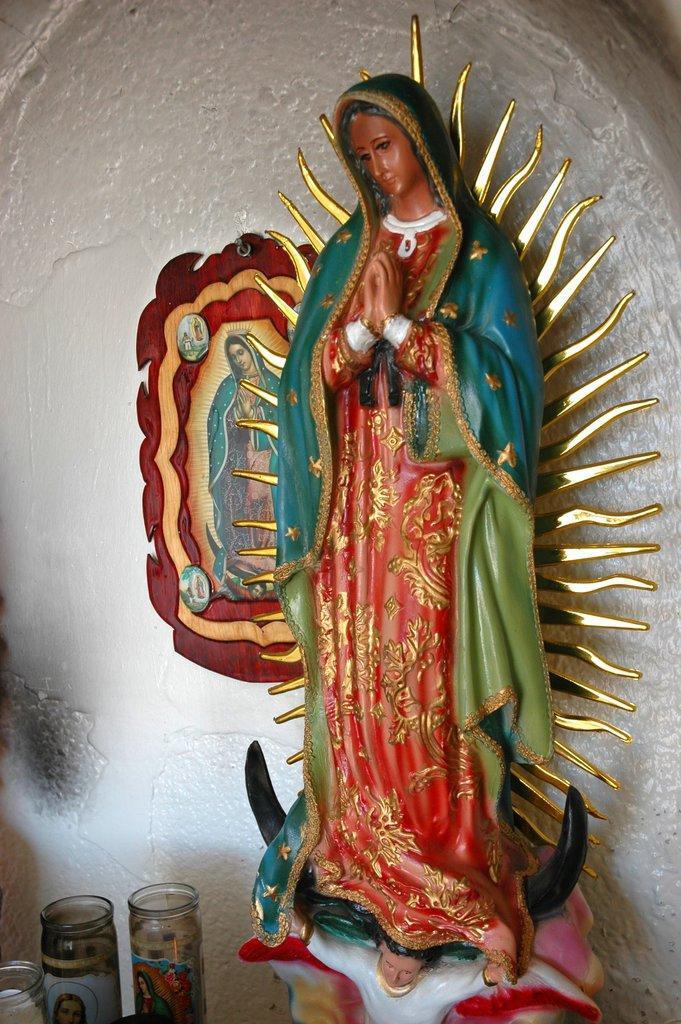In one or two sentences, can you explain what this image depicts? In this image there is a sculpture, glass jars, and a frame attached to the wall. 